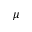Convert formula to latex. <formula><loc_0><loc_0><loc_500><loc_500>\mu</formula> 